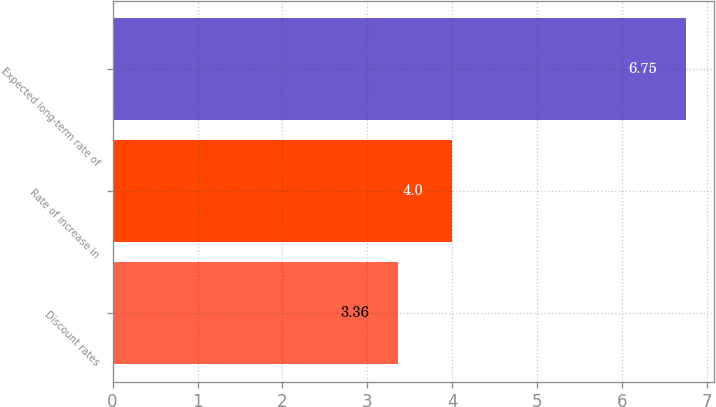Convert chart. <chart><loc_0><loc_0><loc_500><loc_500><bar_chart><fcel>Discount rates<fcel>Rate of increase in<fcel>Expected long-term rate of<nl><fcel>3.36<fcel>4<fcel>6.75<nl></chart> 